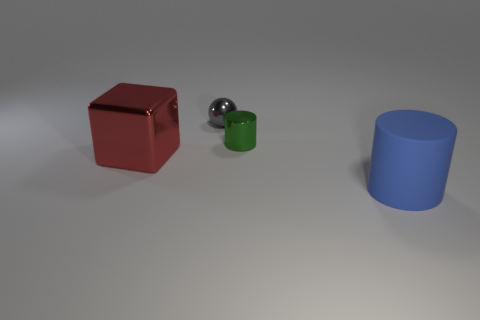What is the color of the small sphere?
Your response must be concise. Gray. There is a blue thing that is in front of the green thing; does it have the same shape as the green thing?
Keep it short and to the point. Yes. Is the number of small green objects that are in front of the red object less than the number of small shiny things that are in front of the small gray shiny ball?
Offer a very short reply. Yes. There is a cylinder in front of the large cube; what is it made of?
Make the answer very short. Rubber. Is there another matte object that has the same size as the gray thing?
Provide a succinct answer. No. There is a tiny green thing; is it the same shape as the large thing that is on the right side of the small green cylinder?
Provide a succinct answer. Yes. There is a cylinder that is on the right side of the shiny cylinder; does it have the same size as the metal object that is on the left side of the tiny gray sphere?
Your response must be concise. Yes. What number of other objects are there of the same shape as the big blue rubber object?
Your answer should be compact. 1. There is a cylinder that is behind the metallic thing that is on the left side of the metal ball; what is its material?
Provide a succinct answer. Metal. How many matte things are either large green cubes or balls?
Provide a short and direct response. 0. 